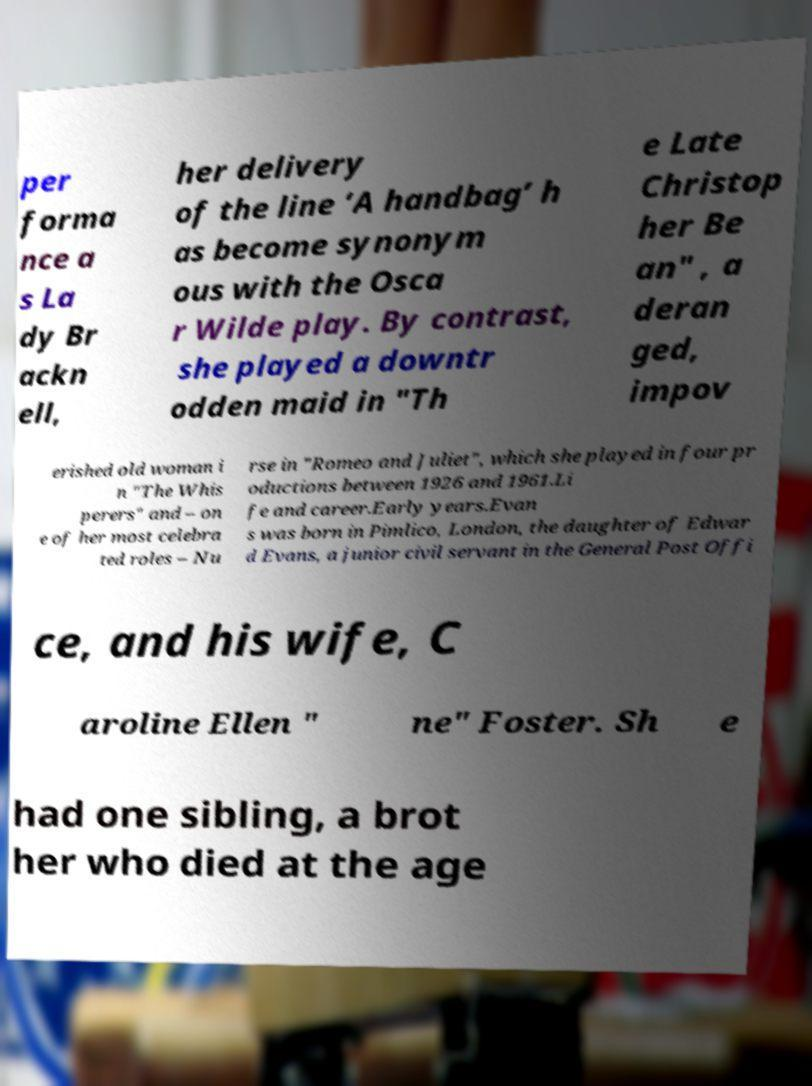Could you extract and type out the text from this image? per forma nce a s La dy Br ackn ell, her delivery of the line ‘A handbag’ h as become synonym ous with the Osca r Wilde play. By contrast, she played a downtr odden maid in "Th e Late Christop her Be an" , a deran ged, impov erished old woman i n "The Whis perers" and – on e of her most celebra ted roles – Nu rse in "Romeo and Juliet", which she played in four pr oductions between 1926 and 1961.Li fe and career.Early years.Evan s was born in Pimlico, London, the daughter of Edwar d Evans, a junior civil servant in the General Post Offi ce, and his wife, C aroline Ellen " ne" Foster. Sh e had one sibling, a brot her who died at the age 